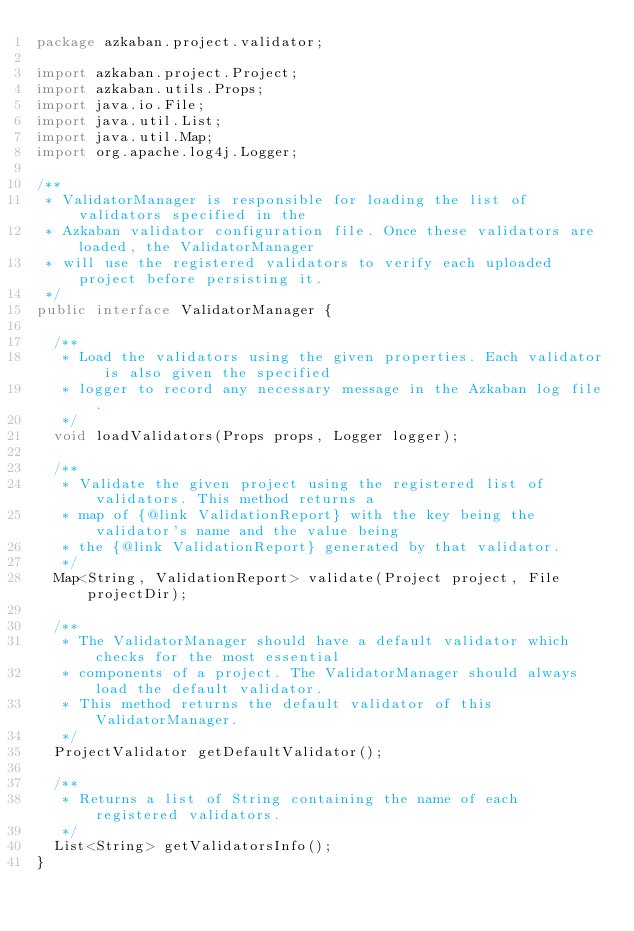Convert code to text. <code><loc_0><loc_0><loc_500><loc_500><_Java_>package azkaban.project.validator;

import azkaban.project.Project;
import azkaban.utils.Props;
import java.io.File;
import java.util.List;
import java.util.Map;
import org.apache.log4j.Logger;

/**
 * ValidatorManager is responsible for loading the list of validators specified in the
 * Azkaban validator configuration file. Once these validators are loaded, the ValidatorManager
 * will use the registered validators to verify each uploaded project before persisting it.
 */
public interface ValidatorManager {

  /**
   * Load the validators using the given properties. Each validator is also given the specified
   * logger to record any necessary message in the Azkaban log file.
   */
  void loadValidators(Props props, Logger logger);

  /**
   * Validate the given project using the registered list of validators. This method returns a
   * map of {@link ValidationReport} with the key being the validator's name and the value being
   * the {@link ValidationReport} generated by that validator.
   */
  Map<String, ValidationReport> validate(Project project, File projectDir);

  /**
   * The ValidatorManager should have a default validator which checks for the most essential
   * components of a project. The ValidatorManager should always load the default validator.
   * This method returns the default validator of this ValidatorManager.
   */
  ProjectValidator getDefaultValidator();

  /**
   * Returns a list of String containing the name of each registered validators.
   */
  List<String> getValidatorsInfo();
}
</code> 